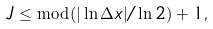Convert formula to latex. <formula><loc_0><loc_0><loc_500><loc_500>J \leq \bmod ( | \ln \Delta x | / \ln 2 ) + 1 ,</formula> 